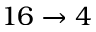Convert formula to latex. <formula><loc_0><loc_0><loc_500><loc_500>1 6 \rightarrow 4</formula> 